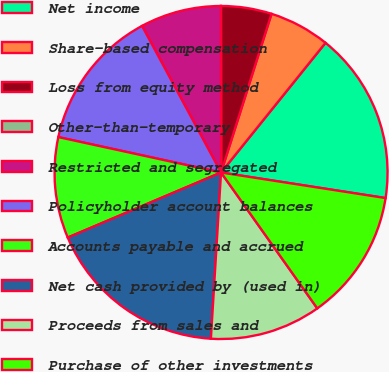Convert chart. <chart><loc_0><loc_0><loc_500><loc_500><pie_chart><fcel>Net income<fcel>Share-based compensation<fcel>Loss from equity method<fcel>Other-than-temporary<fcel>Restricted and segregated<fcel>Policyholder account balances<fcel>Accounts payable and accrued<fcel>Net cash provided by (used in)<fcel>Proceeds from sales and<fcel>Purchase of other investments<nl><fcel>16.66%<fcel>5.89%<fcel>4.91%<fcel>0.01%<fcel>7.85%<fcel>13.72%<fcel>9.8%<fcel>17.64%<fcel>10.78%<fcel>12.74%<nl></chart> 